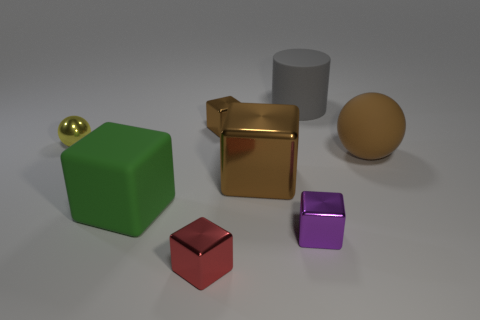What materials do the objects seem to be made of? Several objects in the image have distinct materials: the cube and the sphere seem to be of a matte rubber-like material, the small and large cubes appear metallic, and the cylinder and the small block could be of a plastic or acrylic material. Can you describe the colors of these objects? Certainly! Starting from the left, there's a green rubber cube, a gold metallic cube, a red block that is perhaps made of plastic, a purple geometric shape, a grayish-cylinder, and finally a sphere which has a hue similar to beige. 